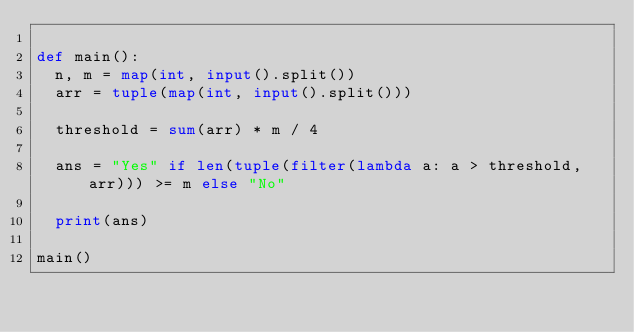Convert code to text. <code><loc_0><loc_0><loc_500><loc_500><_Python_>
def main():
  n, m = map(int, input().split())
  arr = tuple(map(int, input().split()))

  threshold = sum(arr) * m / 4

  ans = "Yes" if len(tuple(filter(lambda a: a > threshold, arr))) >= m else "No"

  print(ans)

main()
</code> 